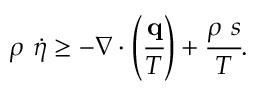Convert formula to latex. <formula><loc_0><loc_0><loc_500><loc_500>\rho { \dot { \eta } } \geq - { \nabla } \cdot \left ( { \cfrac { q } { T } } \right ) + { \cfrac { \rho s } { T } } .</formula> 